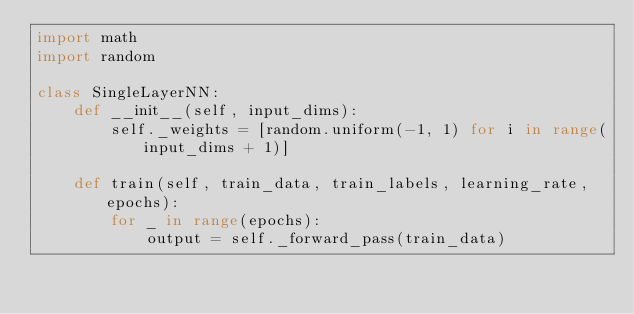Convert code to text. <code><loc_0><loc_0><loc_500><loc_500><_Python_>import math
import random

class SingleLayerNN:
    def __init__(self, input_dims):
        self._weights = [random.uniform(-1, 1) for i in range(input_dims + 1)]

    def train(self, train_data, train_labels, learning_rate, epochs):
        for _ in range(epochs):
            output = self._forward_pass(train_data)</code> 